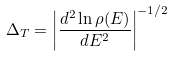<formula> <loc_0><loc_0><loc_500><loc_500>\Delta _ { T } = \left | \frac { d ^ { 2 } \ln \rho ( E ) } { d E ^ { 2 } } \right | ^ { - 1 / 2 }</formula> 